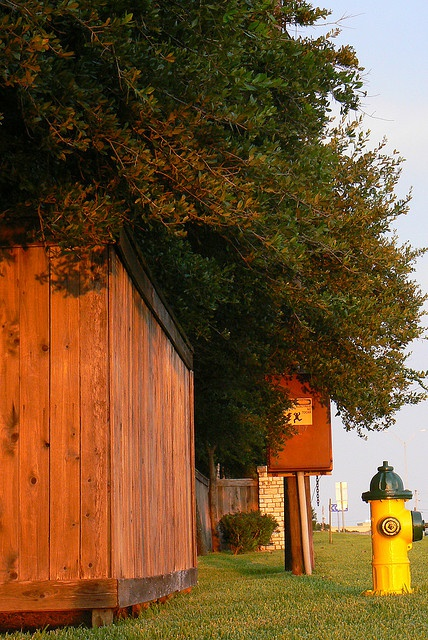Describe the objects in this image and their specific colors. I can see a fire hydrant in black, gold, orange, and lightgray tones in this image. 